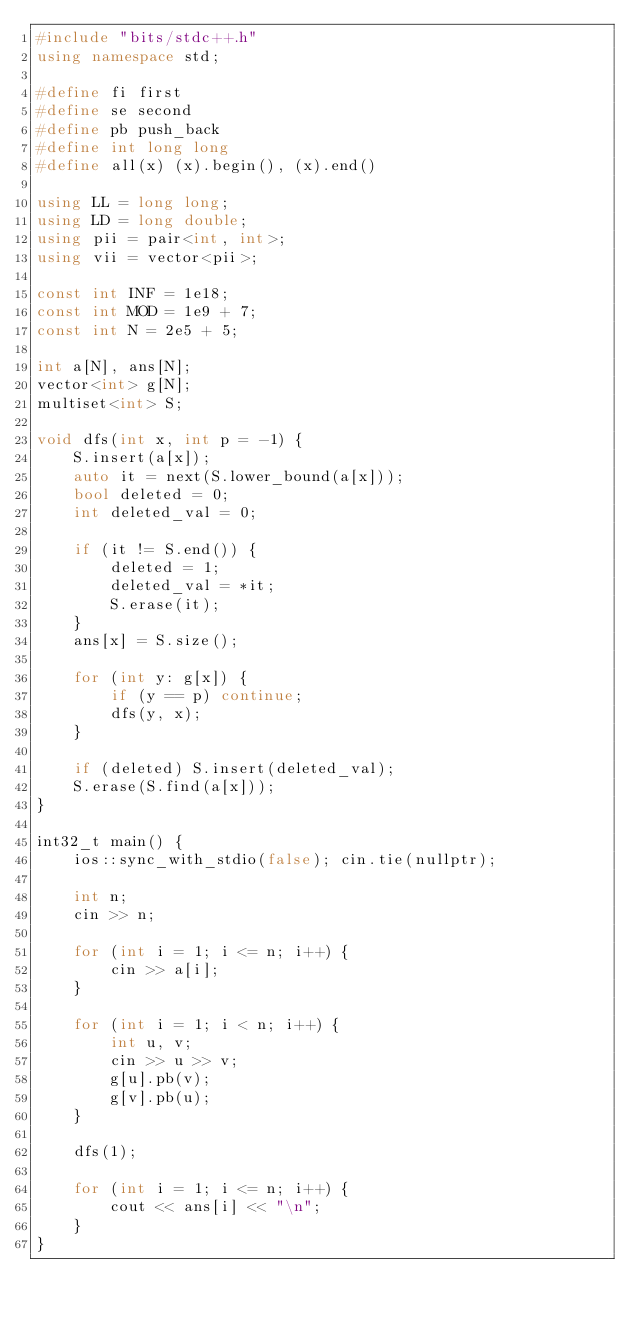Convert code to text. <code><loc_0><loc_0><loc_500><loc_500><_C++_>#include "bits/stdc++.h"
using namespace std;

#define fi first
#define se second
#define pb push_back
#define int long long
#define all(x) (x).begin(), (x).end()

using LL = long long;
using LD = long double;
using pii = pair<int, int>;
using vii = vector<pii>;

const int INF = 1e18;
const int MOD = 1e9 + 7;
const int N = 2e5 + 5;

int a[N], ans[N];
vector<int> g[N];
multiset<int> S;

void dfs(int x, int p = -1) {
    S.insert(a[x]);
    auto it = next(S.lower_bound(a[x]));
    bool deleted = 0;
    int deleted_val = 0;
    
    if (it != S.end()) {
        deleted = 1;
        deleted_val = *it;
        S.erase(it);
    }
    ans[x] = S.size();
    
    for (int y: g[x]) {
        if (y == p) continue;
        dfs(y, x);
    }
    
    if (deleted) S.insert(deleted_val);
    S.erase(S.find(a[x]));
}

int32_t main() {
    ios::sync_with_stdio(false); cin.tie(nullptr);

    int n;
    cin >> n;

    for (int i = 1; i <= n; i++) {
        cin >> a[i];
    }

    for (int i = 1; i < n; i++) {
        int u, v;
        cin >> u >> v;
        g[u].pb(v);
        g[v].pb(u);
    }

    dfs(1);

    for (int i = 1; i <= n; i++) {
        cout << ans[i] << "\n";
    }
}</code> 